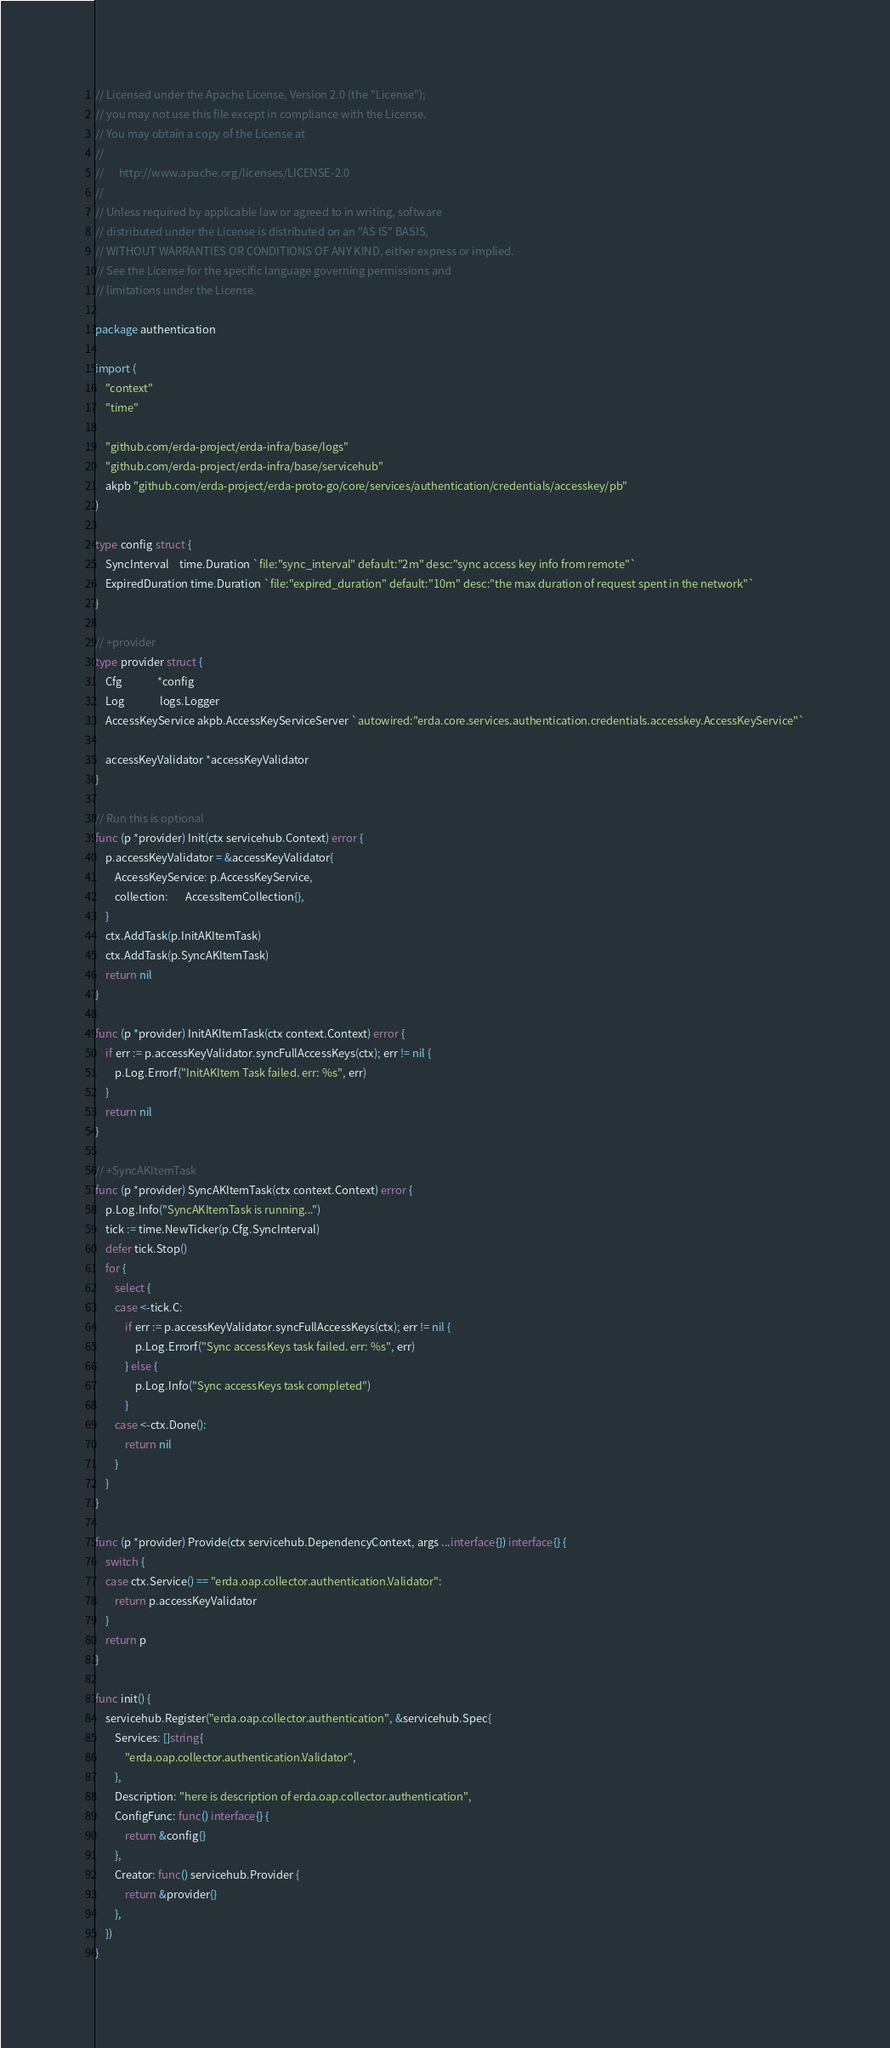Convert code to text. <code><loc_0><loc_0><loc_500><loc_500><_Go_>// Licensed under the Apache License, Version 2.0 (the "License");
// you may not use this file except in compliance with the License.
// You may obtain a copy of the License at
//
//      http://www.apache.org/licenses/LICENSE-2.0
//
// Unless required by applicable law or agreed to in writing, software
// distributed under the License is distributed on an "AS IS" BASIS,
// WITHOUT WARRANTIES OR CONDITIONS OF ANY KIND, either express or implied.
// See the License for the specific language governing permissions and
// limitations under the License.

package authentication

import (
	"context"
	"time"

	"github.com/erda-project/erda-infra/base/logs"
	"github.com/erda-project/erda-infra/base/servicehub"
	akpb "github.com/erda-project/erda-proto-go/core/services/authentication/credentials/accesskey/pb"
)

type config struct {
	SyncInterval    time.Duration `file:"sync_interval" default:"2m" desc:"sync access key info from remote"`
	ExpiredDuration time.Duration `file:"expired_duration" default:"10m" desc:"the max duration of request spent in the network"`
}

// +provider
type provider struct {
	Cfg              *config
	Log              logs.Logger
	AccessKeyService akpb.AccessKeyServiceServer `autowired:"erda.core.services.authentication.credentials.accesskey.AccessKeyService"`

	accessKeyValidator *accessKeyValidator
}

// Run this is optional
func (p *provider) Init(ctx servicehub.Context) error {
	p.accessKeyValidator = &accessKeyValidator{
		AccessKeyService: p.AccessKeyService,
		collection:       AccessItemCollection{},
	}
	ctx.AddTask(p.InitAKItemTask)
	ctx.AddTask(p.SyncAKItemTask)
	return nil
}

func (p *provider) InitAKItemTask(ctx context.Context) error {
	if err := p.accessKeyValidator.syncFullAccessKeys(ctx); err != nil {
		p.Log.Errorf("InitAKItem Task failed. err: %s", err)
	}
	return nil
}

// +SyncAKItemTask
func (p *provider) SyncAKItemTask(ctx context.Context) error {
	p.Log.Info("SyncAKItemTask is running...")
	tick := time.NewTicker(p.Cfg.SyncInterval)
	defer tick.Stop()
	for {
		select {
		case <-tick.C:
			if err := p.accessKeyValidator.syncFullAccessKeys(ctx); err != nil {
				p.Log.Errorf("Sync accessKeys task failed. err: %s", err)
			} else {
				p.Log.Info("Sync accessKeys task completed")
			}
		case <-ctx.Done():
			return nil
		}
	}
}

func (p *provider) Provide(ctx servicehub.DependencyContext, args ...interface{}) interface{} {
	switch {
	case ctx.Service() == "erda.oap.collector.authentication.Validator":
		return p.accessKeyValidator
	}
	return p
}

func init() {
	servicehub.Register("erda.oap.collector.authentication", &servicehub.Spec{
		Services: []string{
			"erda.oap.collector.authentication.Validator",
		},
		Description: "here is description of erda.oap.collector.authentication",
		ConfigFunc: func() interface{} {
			return &config{}
		},
		Creator: func() servicehub.Provider {
			return &provider{}
		},
	})
}
</code> 